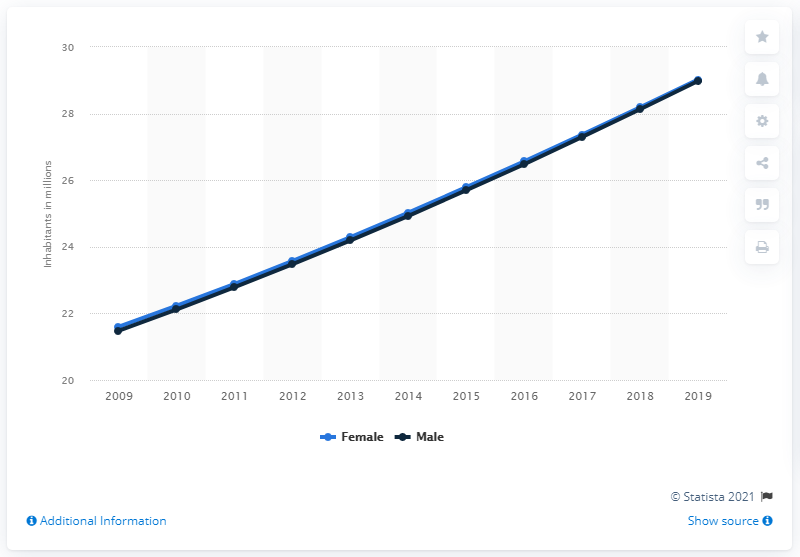Outline some significant characteristics in this image. In 2019, the female population of Tanzania was 29.02%. The male population of Tanzania in 2019 was approximately 29.02 million. 